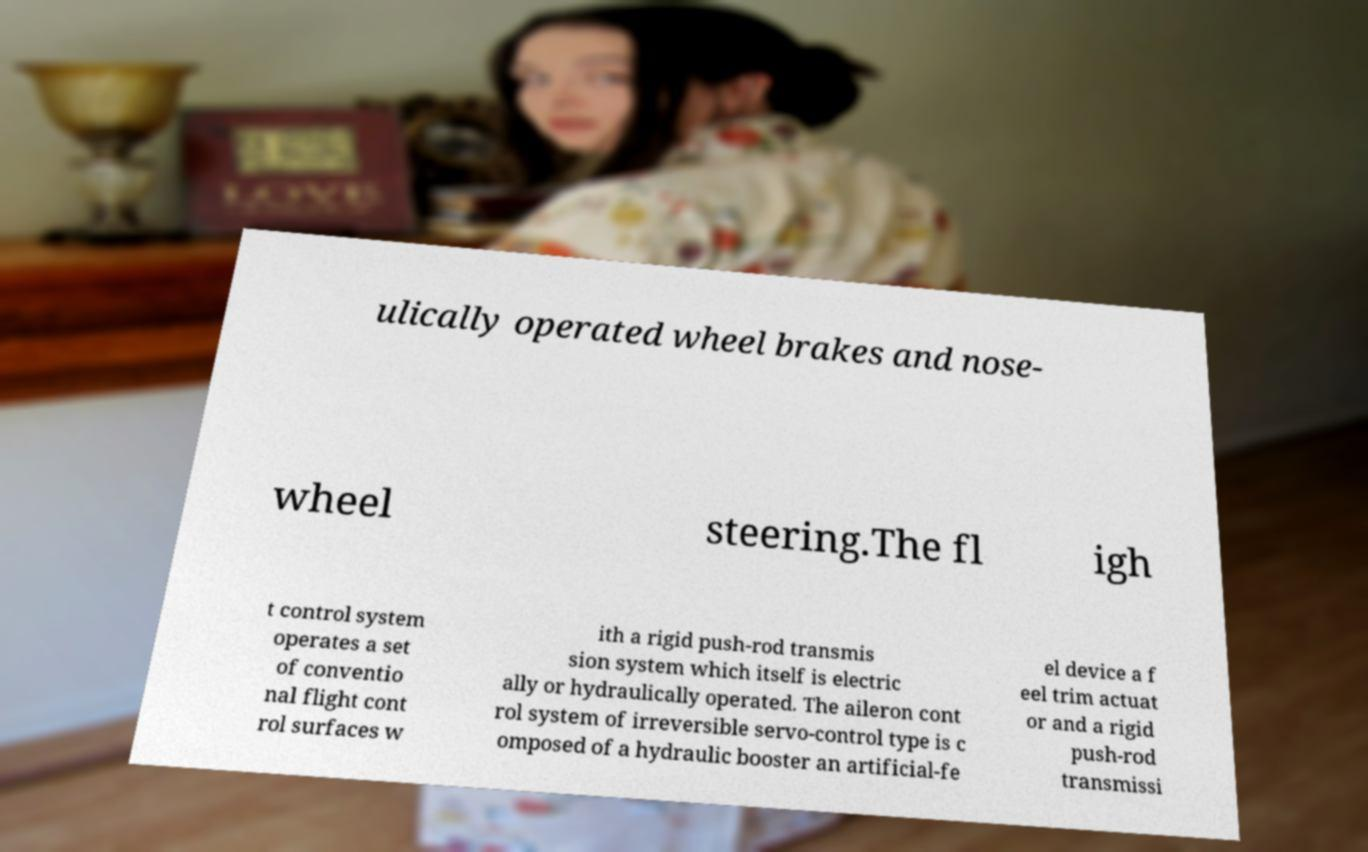Can you accurately transcribe the text from the provided image for me? ulically operated wheel brakes and nose- wheel steering.The fl igh t control system operates a set of conventio nal flight cont rol surfaces w ith a rigid push-rod transmis sion system which itself is electric ally or hydraulically operated. The aileron cont rol system of irreversible servo-control type is c omposed of a hydraulic booster an artificial-fe el device a f eel trim actuat or and a rigid push-rod transmissi 